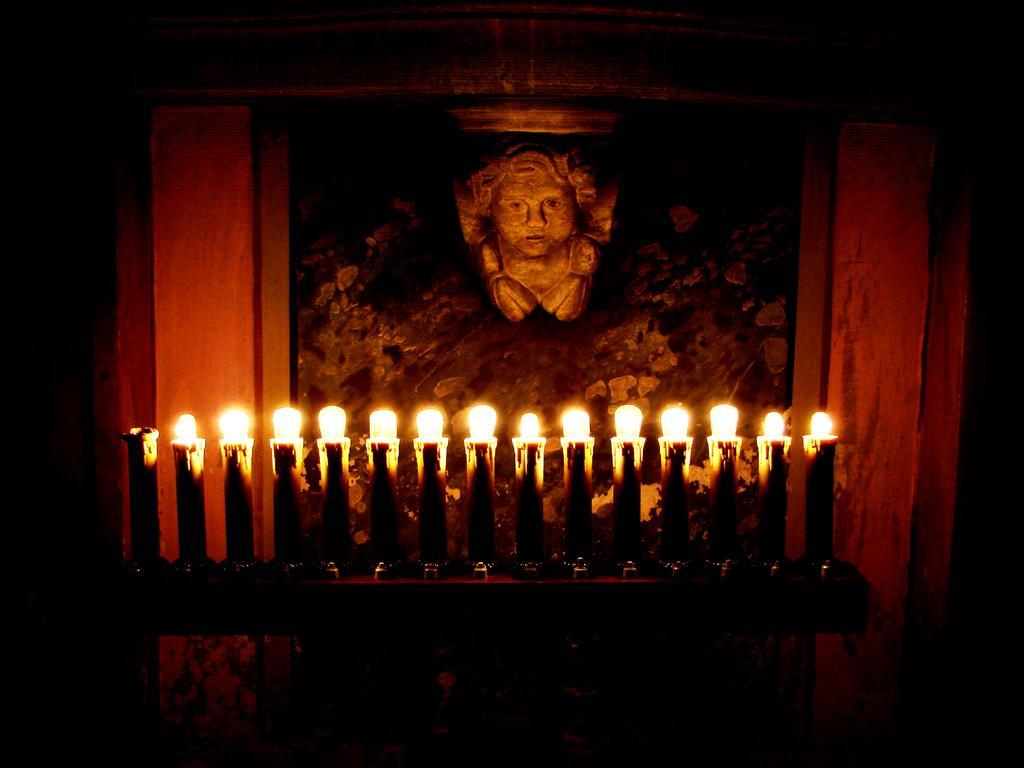Could you give a brief overview of what you see in this image? In this image there are candles on the platform. Behind the candles there is a photo frame on the wall. 